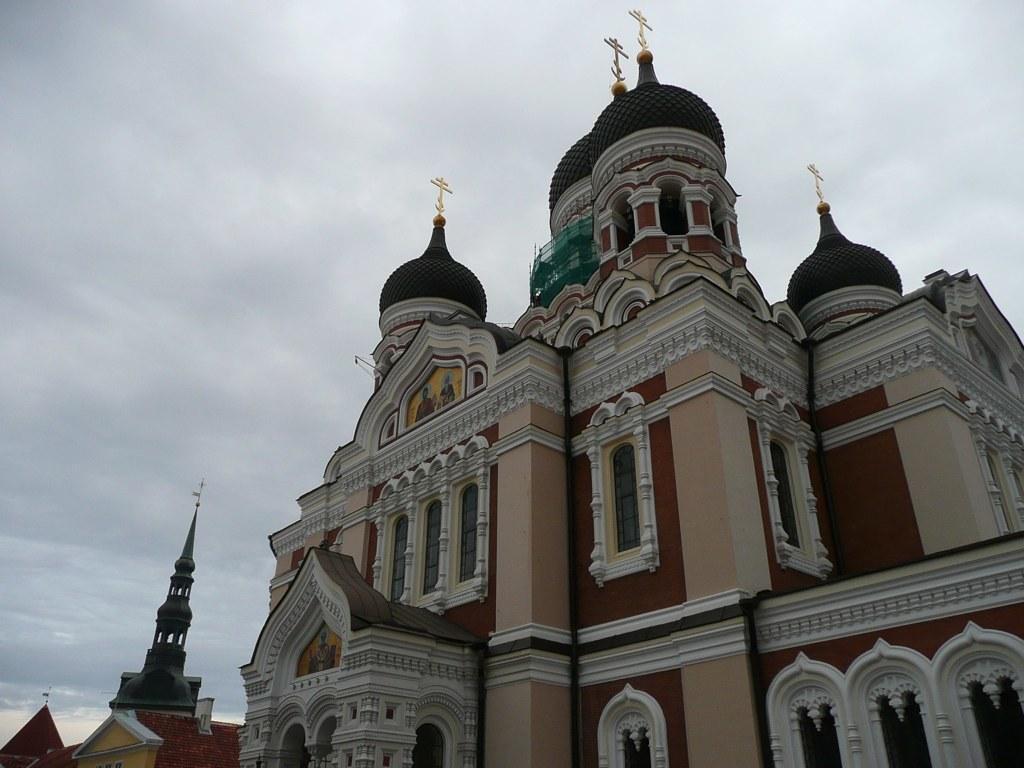Please provide a concise description of this image. In this picture there is a building in the center of the image. 